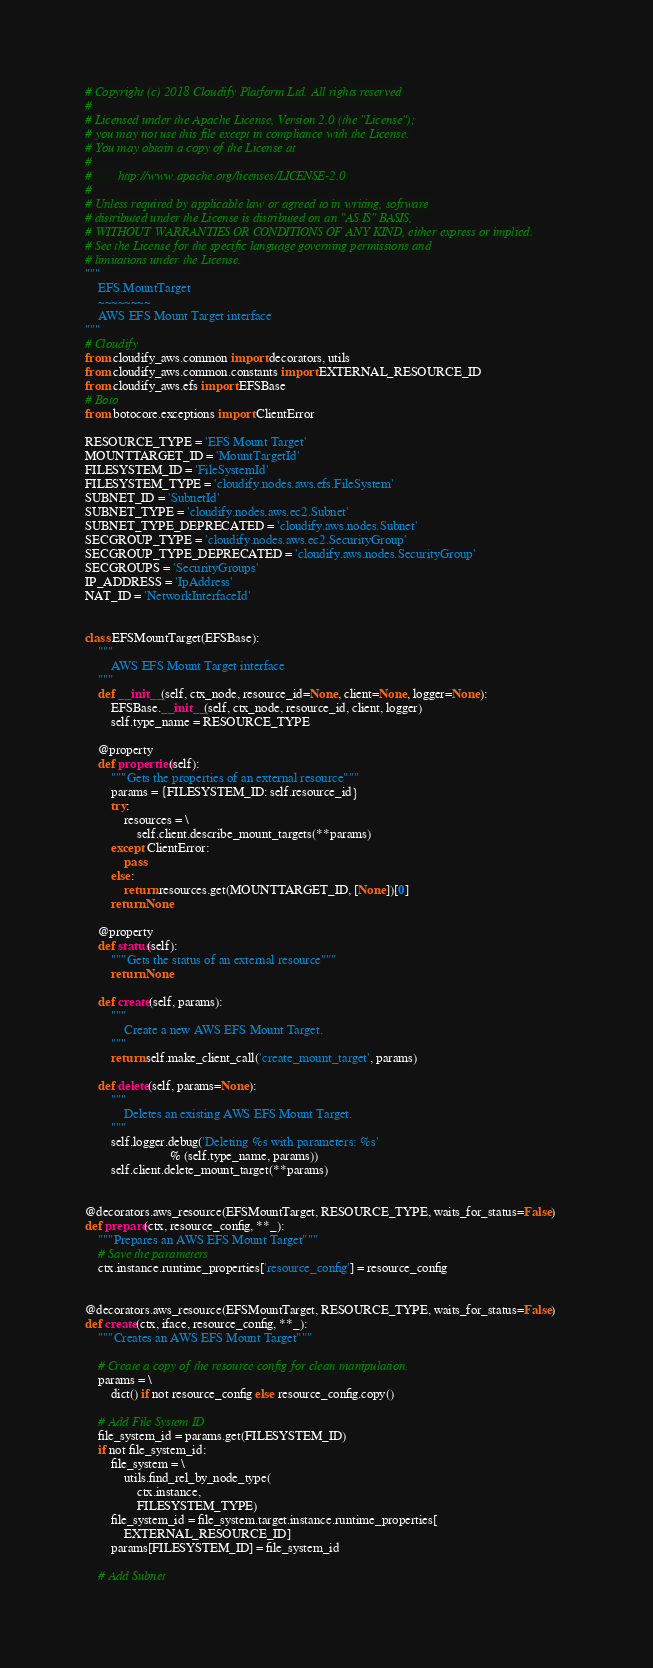Convert code to text. <code><loc_0><loc_0><loc_500><loc_500><_Python_># Copyright (c) 2018 Cloudify Platform Ltd. All rights reserved
#
# Licensed under the Apache License, Version 2.0 (the "License");
# you may not use this file except in compliance with the License.
# You may obtain a copy of the License at
#
#        http://www.apache.org/licenses/LICENSE-2.0
#
# Unless required by applicable law or agreed to in writing, software
# distributed under the License is distributed on an "AS IS" BASIS,
# WITHOUT WARRANTIES OR CONDITIONS OF ANY KIND, either express or implied.
# See the License for the specific language governing permissions and
# limitations under the License.
"""
    EFS.MountTarget
    ~~~~~~~~
    AWS EFS Mount Target interface
"""
# Cloudify
from cloudify_aws.common import decorators, utils
from cloudify_aws.common.constants import EXTERNAL_RESOURCE_ID
from cloudify_aws.efs import EFSBase
# Boto
from botocore.exceptions import ClientError

RESOURCE_TYPE = 'EFS Mount Target'
MOUNTTARGET_ID = 'MountTargetId'
FILESYSTEM_ID = 'FileSystemId'
FILESYSTEM_TYPE = 'cloudify.nodes.aws.efs.FileSystem'
SUBNET_ID = 'SubnetId'
SUBNET_TYPE = 'cloudify.nodes.aws.ec2.Subnet'
SUBNET_TYPE_DEPRECATED = 'cloudify.aws.nodes.Subnet'
SECGROUP_TYPE = 'cloudify.nodes.aws.ec2.SecurityGroup'
SECGROUP_TYPE_DEPRECATED = 'cloudify.aws.nodes.SecurityGroup'
SECGROUPS = 'SecurityGroups'
IP_ADDRESS = 'IpAddress'
NAT_ID = 'NetworkInterfaceId'


class EFSMountTarget(EFSBase):
    """
        AWS EFS Mount Target interface
    """
    def __init__(self, ctx_node, resource_id=None, client=None, logger=None):
        EFSBase.__init__(self, ctx_node, resource_id, client, logger)
        self.type_name = RESOURCE_TYPE

    @property
    def properties(self):
        """Gets the properties of an external resource"""
        params = {FILESYSTEM_ID: self.resource_id}
        try:
            resources = \
                self.client.describe_mount_targets(**params)
        except ClientError:
            pass
        else:
            return resources.get(MOUNTTARGET_ID, [None])[0]
        return None

    @property
    def status(self):
        """Gets the status of an external resource"""
        return None

    def create(self, params):
        """
            Create a new AWS EFS Mount Target.
        """
        return self.make_client_call('create_mount_target', params)

    def delete(self, params=None):
        """
            Deletes an existing AWS EFS Mount Target.
        """
        self.logger.debug('Deleting %s with parameters: %s'
                          % (self.type_name, params))
        self.client.delete_mount_target(**params)


@decorators.aws_resource(EFSMountTarget, RESOURCE_TYPE, waits_for_status=False)
def prepare(ctx, resource_config, **_):
    """Prepares an AWS EFS Mount Target"""
    # Save the parameters
    ctx.instance.runtime_properties['resource_config'] = resource_config


@decorators.aws_resource(EFSMountTarget, RESOURCE_TYPE, waits_for_status=False)
def create(ctx, iface, resource_config, **_):
    """Creates an AWS EFS Mount Target"""

    # Create a copy of the resource config for clean manipulation.
    params = \
        dict() if not resource_config else resource_config.copy()

    # Add File System ID
    file_system_id = params.get(FILESYSTEM_ID)
    if not file_system_id:
        file_system = \
            utils.find_rel_by_node_type(
                ctx.instance,
                FILESYSTEM_TYPE)
        file_system_id = file_system.target.instance.runtime_properties[
            EXTERNAL_RESOURCE_ID]
        params[FILESYSTEM_ID] = file_system_id

    # Add Subnet</code> 